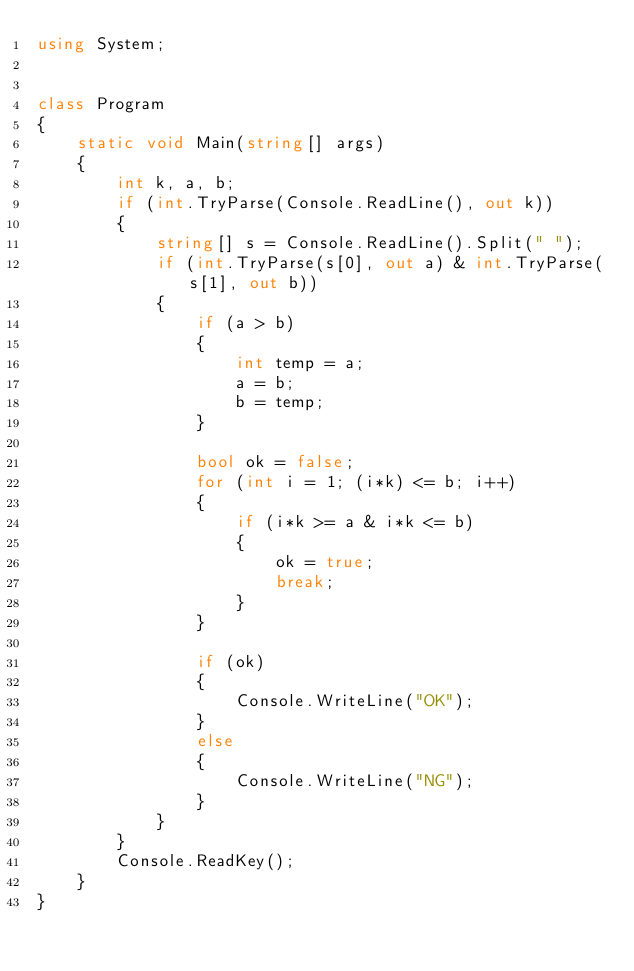<code> <loc_0><loc_0><loc_500><loc_500><_C#_>using System;


class Program
{
    static void Main(string[] args)
    {
        int k, a, b;
        if (int.TryParse(Console.ReadLine(), out k))
        {
            string[] s = Console.ReadLine().Split(" ");
            if (int.TryParse(s[0], out a) & int.TryParse(s[1], out b))
            {
                if (a > b)
                {
                    int temp = a;
                    a = b;
                    b = temp;
                }

                bool ok = false;
                for (int i = 1; (i*k) <= b; i++)
                {
                    if (i*k >= a & i*k <= b)
                    {
                        ok = true;
                        break;
                    }
                }

                if (ok)
                {
                    Console.WriteLine("OK");
                }
                else
                {
                    Console.WriteLine("NG");
                }
            }
        }
        Console.ReadKey();
    }
}
</code> 